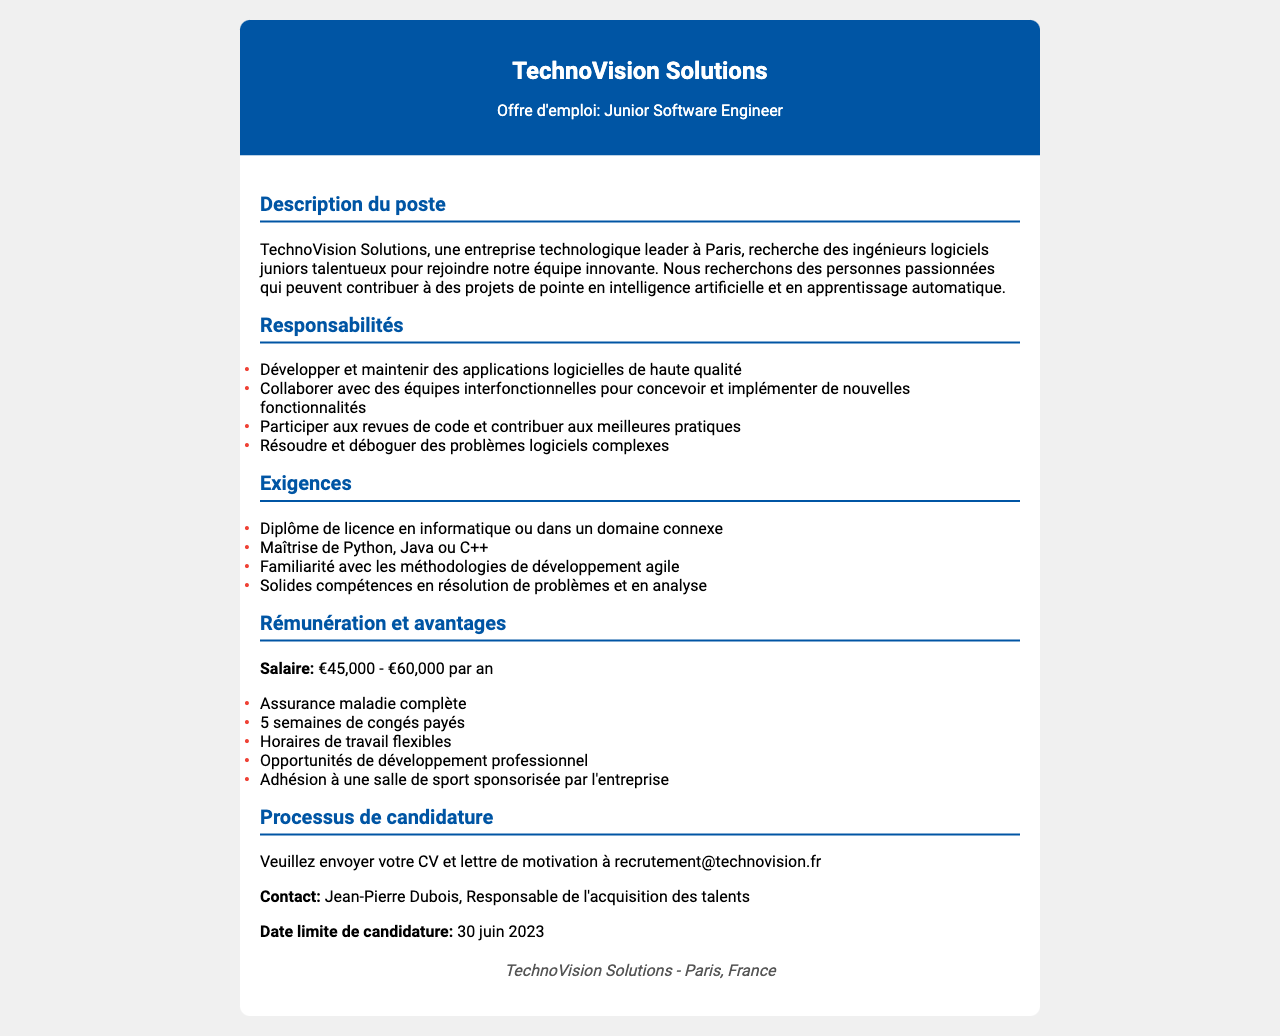Quel est le nom de l'entreprise ? Le nom de l'entreprise est mentionné en haut du document dans l'en-tête.
Answer: TechnoVision Solutions Quel est le titre du poste proposé ? Le titre du poste est indiqué sous le nom de l'entreprise dans l'en-tête.
Answer: Junior Software Engineer Quelle est la fourchette salariale pour ce poste ? La fourchette salariale est indiquée dans la section "Rémunération et avantages".
Answer: €45,000 - €60,000 par an Quelle est la date limite de candidature ? La date limite de candidature est mentionnée dans le processus de candidature.
Answer: 30 juin 2023 Quels sont les deux langages de programmation requis ? Les langages de programmation requis sont listés dans la section "Exigences".
Answer: Python, Java ou C++ Quelles sont les responsabilités principales du poste ? Les responsabilités sont détaillées dans une liste sous la section "Responsabilités".
Answer: Développer et maintenir des applications logicielles de haute qualité Quels avantages sont offerts avec ce poste ? Les avantages sont énumérés dans la section "Rémunération et avantages".
Answer: Assurance maladie complète Qui est le contact pour les candidatures ? Le contact est indiqué dans la section "Processus de candidature".
Answer: Jean-Pierre Dubois Combien de semaines de congés payés sont offertes ? Le nombre de semaines de congés payés est spécifié dans la section "Rémunération et avantages".
Answer: 5 semaines 